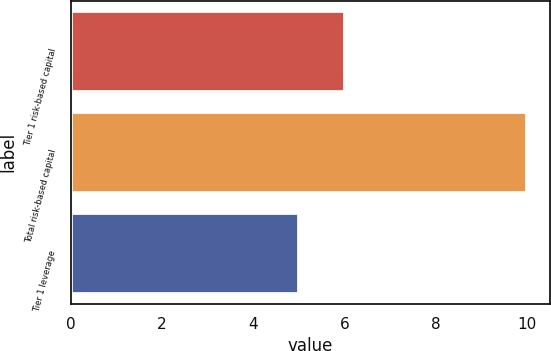Convert chart. <chart><loc_0><loc_0><loc_500><loc_500><bar_chart><fcel>Tier 1 risk-based capital<fcel>Total risk-based capital<fcel>Tier 1 leverage<nl><fcel>6<fcel>10<fcel>5<nl></chart> 